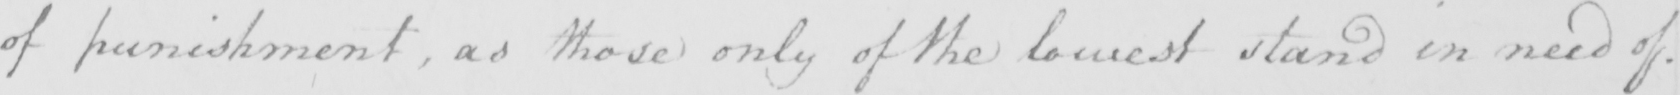What text is written in this handwritten line? of punishment , as those only of the lowest stand in need of . 